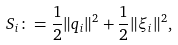Convert formula to latex. <formula><loc_0><loc_0><loc_500><loc_500>S _ { i } \colon = \frac { 1 } { 2 } \| q _ { i } \| ^ { 2 } + \frac { 1 } { 2 } \| \xi _ { i } \| ^ { 2 } ,</formula> 